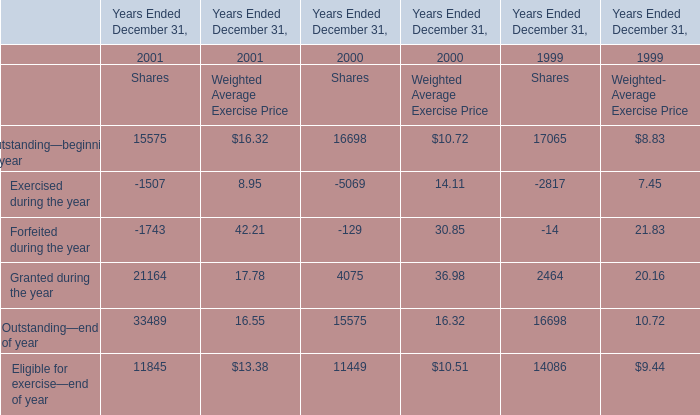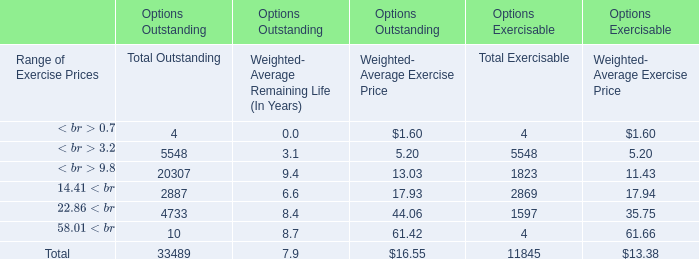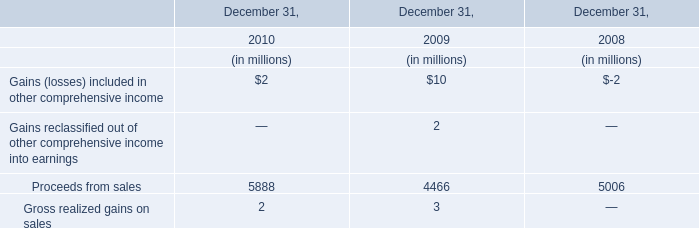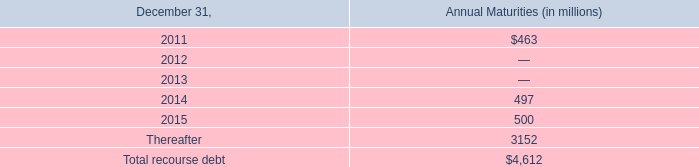What's the average of granted in 1999, 2000, and 2001? (in million) 
Computations: ((((21164 * 17.78) + (4075 * 36.98)) + (2464 * 20.16)) / 3)
Answer: 192221.22. 